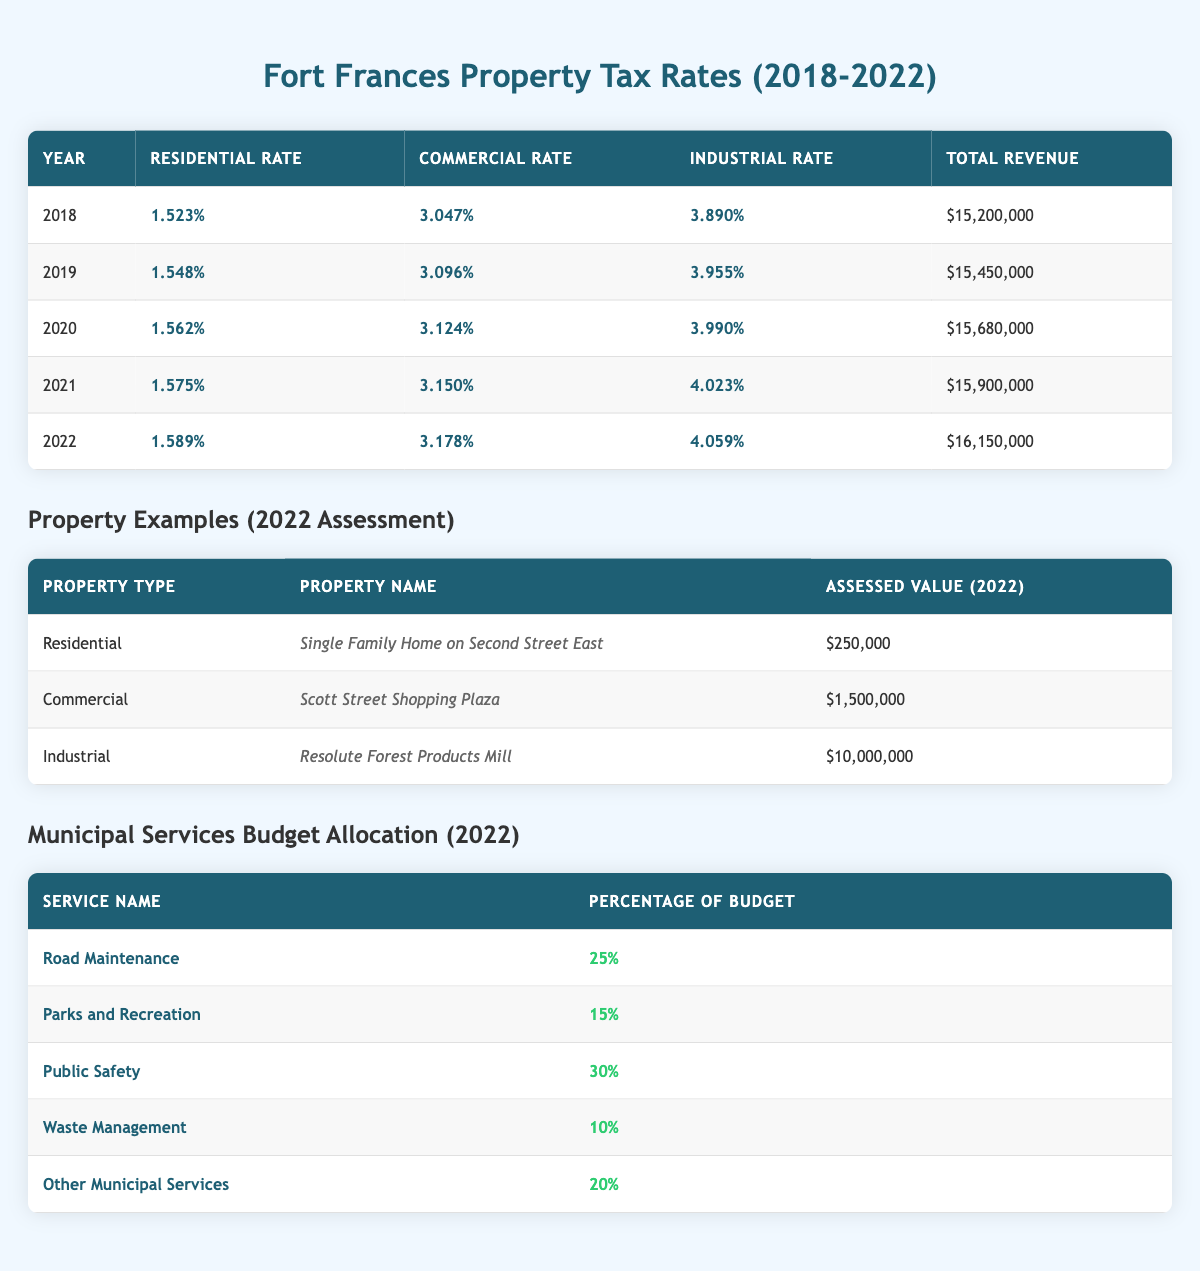What was the residential property tax rate in 2021? Referring to the table, the residential property tax rate for the year 2021 is listed directly under the Residential Rate column. The value is 1.575%.
Answer: 1.575% Which year had the highest commercial property tax rate? To find the year with the highest commercial tax rate, we look at the Commercial Rate column for all years. The highest value is in 2022, which is 3.178%.
Answer: 2022 What was the total tax revenue in 2020 compared to 2019? The total tax revenue for 2020 is $15,680,000, while for 2019 it is $15,450,000. To compare, we see that 2020's revenue is $15,680,000 against $15,450,000 for 2019, showing an increase of $230,000.
Answer: 2020 had higher revenue by $230,000 What is the average residential tax rate from 2018 to 2022? We sum the residential tax rates from 2018 (1.523%), 2019 (1.548%), 2020 (1.562%), 2021 (1.575%), and 2022 (1.589%). The total is 1.523 + 1.548 + 1.562 + 1.575 + 1.589 = 7.797%. Then, dividing by 5 gives an average of 7.797% / 5 = 1.5594%.
Answer: 1.5594% Was the industrial tax rate in 2021 higher than in 2020? The industrial tax rate for 2021 is 4.023% while for 2020 it is 3.990%. Therefore, 4.023% is higher than 3.990%, so the answer is yes.
Answer: Yes What was the increase in total revenue from 2018 to 2022? The total revenue for 2018 is $15,200,000, and for 2022 it is $16,150,000. To find the increase, we subtract the earlier year from the later year: $16,150,000 - $15,200,000 = $950,000.
Answer: $950,000 How much of the 2022 budget was allocated to Public Safety? From the Municipal Services table, Public Safety received 30% of the budget in 2022. This direct value can be found under the Percentage of Budget column next to Public Safety.
Answer: 30% Is the assessed value of the residential property listed above greater than $200,000? The assessed value of the residential property, "Single Family Home on Second Street East," is $250,000. Since $250,000 is greater than $200,000, the answer is yes.
Answer: Yes What service has the largest budget allocation percentage in 2022? By examining the Municipal Services Budget Allocation table, Public Safety has the highest allocation at 30%, followed by Road Maintenance at 25%.
Answer: Public Safety has the largest allocation 